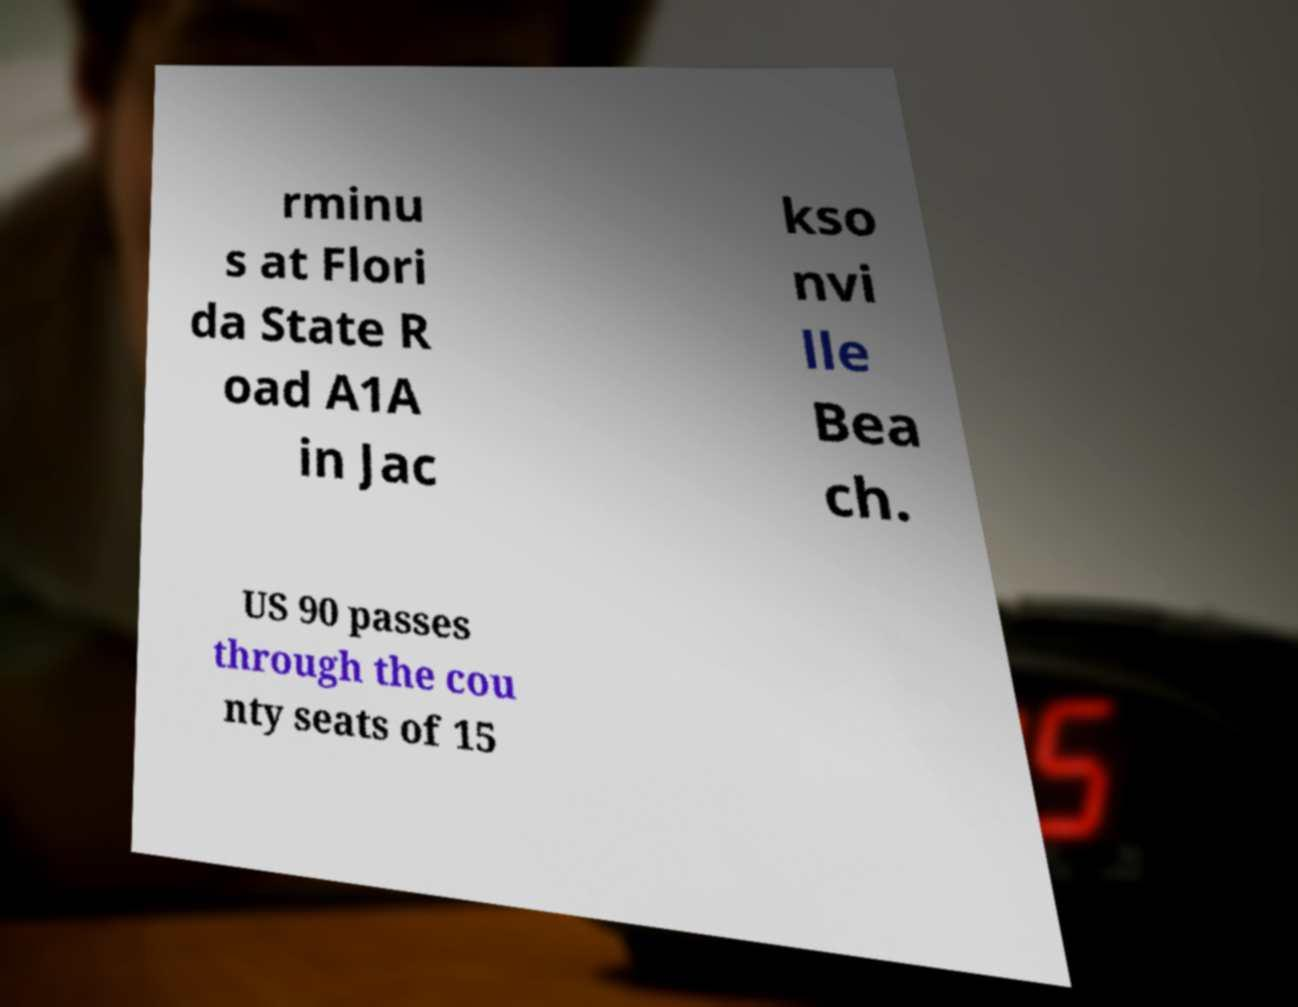I need the written content from this picture converted into text. Can you do that? rminu s at Flori da State R oad A1A in Jac kso nvi lle Bea ch. US 90 passes through the cou nty seats of 15 